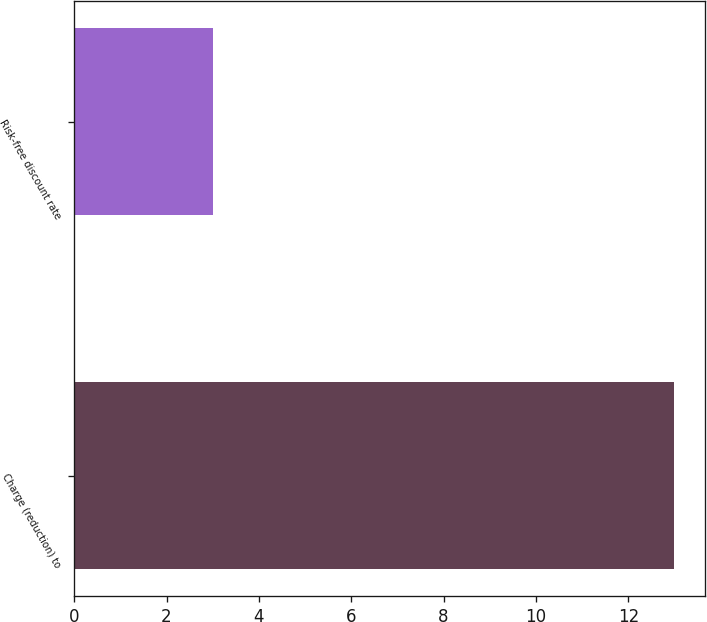<chart> <loc_0><loc_0><loc_500><loc_500><bar_chart><fcel>Charge (reduction) to<fcel>Risk-free discount rate<nl><fcel>13<fcel>3<nl></chart> 